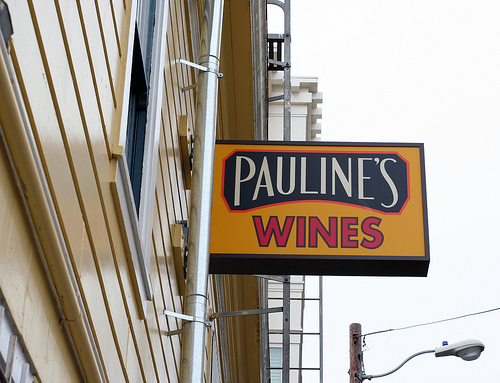<image>
Can you confirm if the sign is behind the pole? No. The sign is not behind the pole. From this viewpoint, the sign appears to be positioned elsewhere in the scene. 